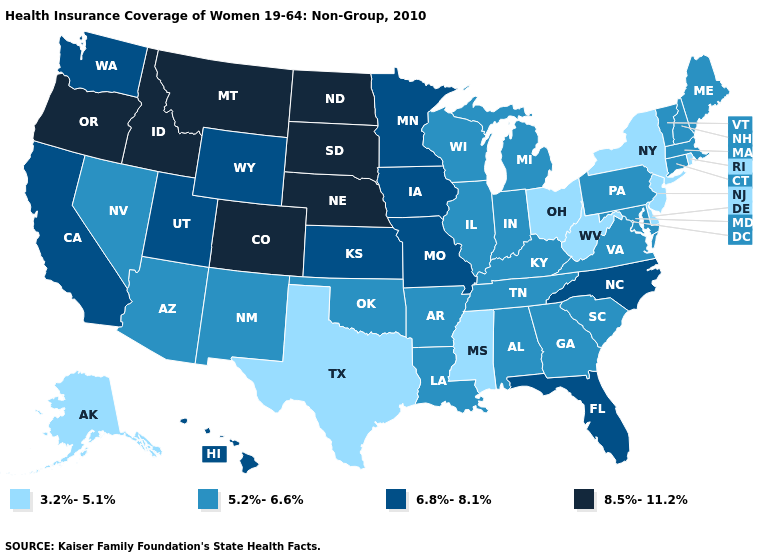Is the legend a continuous bar?
Give a very brief answer. No. What is the lowest value in states that border Iowa?
Concise answer only. 5.2%-6.6%. What is the lowest value in states that border Rhode Island?
Answer briefly. 5.2%-6.6%. What is the value of Kentucky?
Short answer required. 5.2%-6.6%. Does Maine have a higher value than California?
Quick response, please. No. Does Washington have a higher value than Nebraska?
Concise answer only. No. What is the lowest value in states that border Kentucky?
Answer briefly. 3.2%-5.1%. What is the value of Kansas?
Give a very brief answer. 6.8%-8.1%. What is the value of Utah?
Write a very short answer. 6.8%-8.1%. Name the states that have a value in the range 6.8%-8.1%?
Answer briefly. California, Florida, Hawaii, Iowa, Kansas, Minnesota, Missouri, North Carolina, Utah, Washington, Wyoming. What is the value of Kansas?
Concise answer only. 6.8%-8.1%. Does the map have missing data?
Concise answer only. No. Which states hav the highest value in the Northeast?
Answer briefly. Connecticut, Maine, Massachusetts, New Hampshire, Pennsylvania, Vermont. 